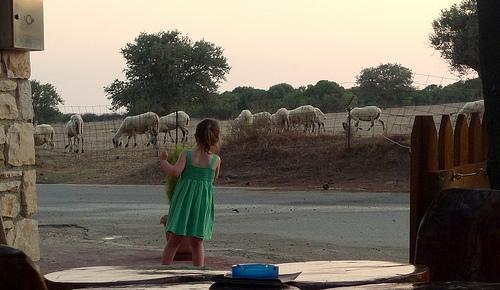How many girls?
Give a very brief answer. 1. 